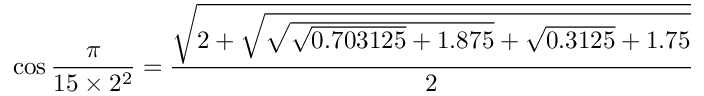<formula> <loc_0><loc_0><loc_500><loc_500>\cos { \frac { \pi } { 1 5 \times 2 ^ { 2 } } } = { \frac { \sqrt { 2 + { \sqrt { { \sqrt { { \sqrt { 0 . 7 0 3 1 2 5 } } + 1 . 8 7 5 } } + { \sqrt { 0 . 3 1 2 5 } } + 1 . 7 5 } } } } { 2 } }</formula> 